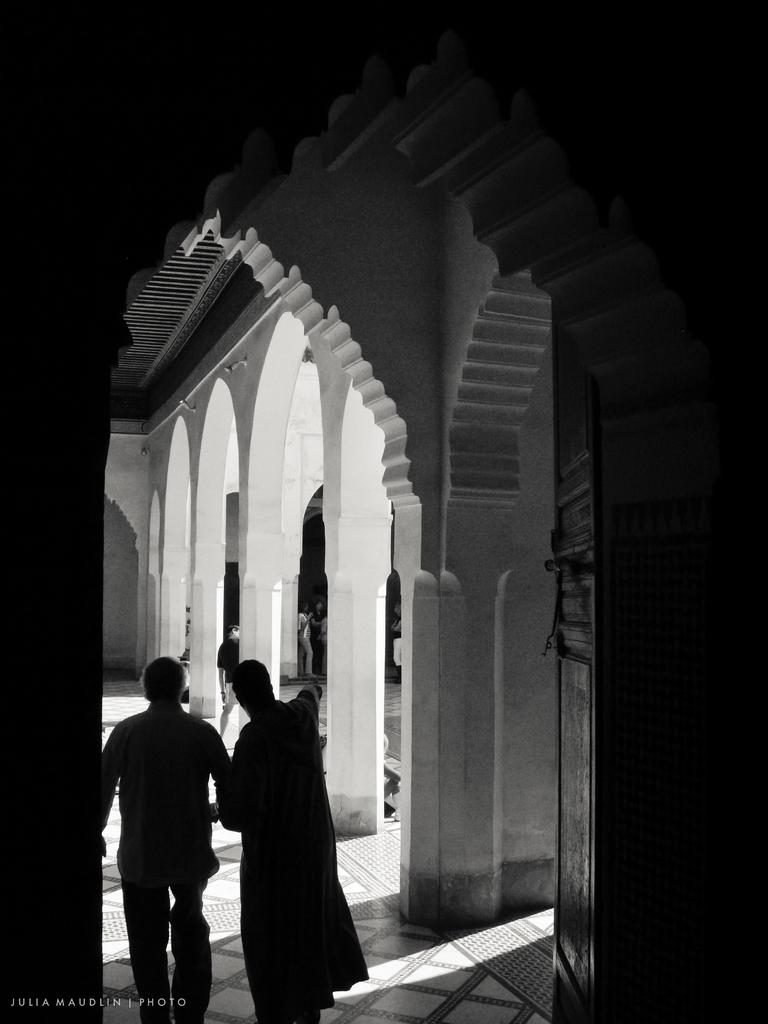What is happening in the foreground of the image? There are people on the ground in the image. What can be seen in the background of the image? There are pillars and a wall in the background of the image. Is there any text present in the image? Yes, there is some text in the bottom left corner of the image. What type of pump is visible in the image? There is no pump present in the image. What angle is the car parked at in the image? There is no car present in the image. 